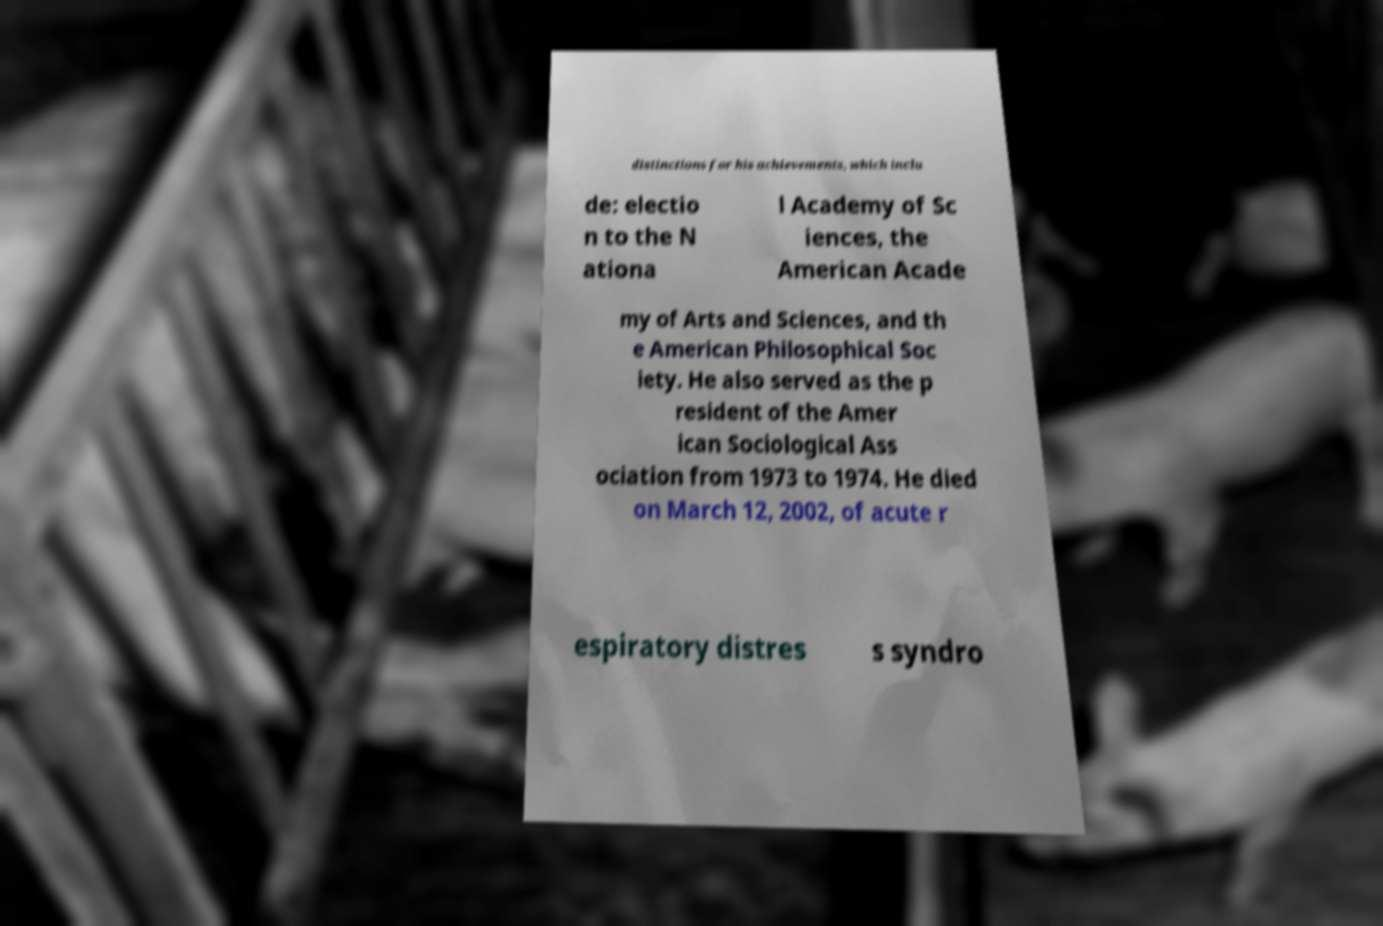Please read and relay the text visible in this image. What does it say? distinctions for his achievements, which inclu de: electio n to the N ationa l Academy of Sc iences, the American Acade my of Arts and Sciences, and th e American Philosophical Soc iety. He also served as the p resident of the Amer ican Sociological Ass ociation from 1973 to 1974. He died on March 12, 2002, of acute r espiratory distres s syndro 